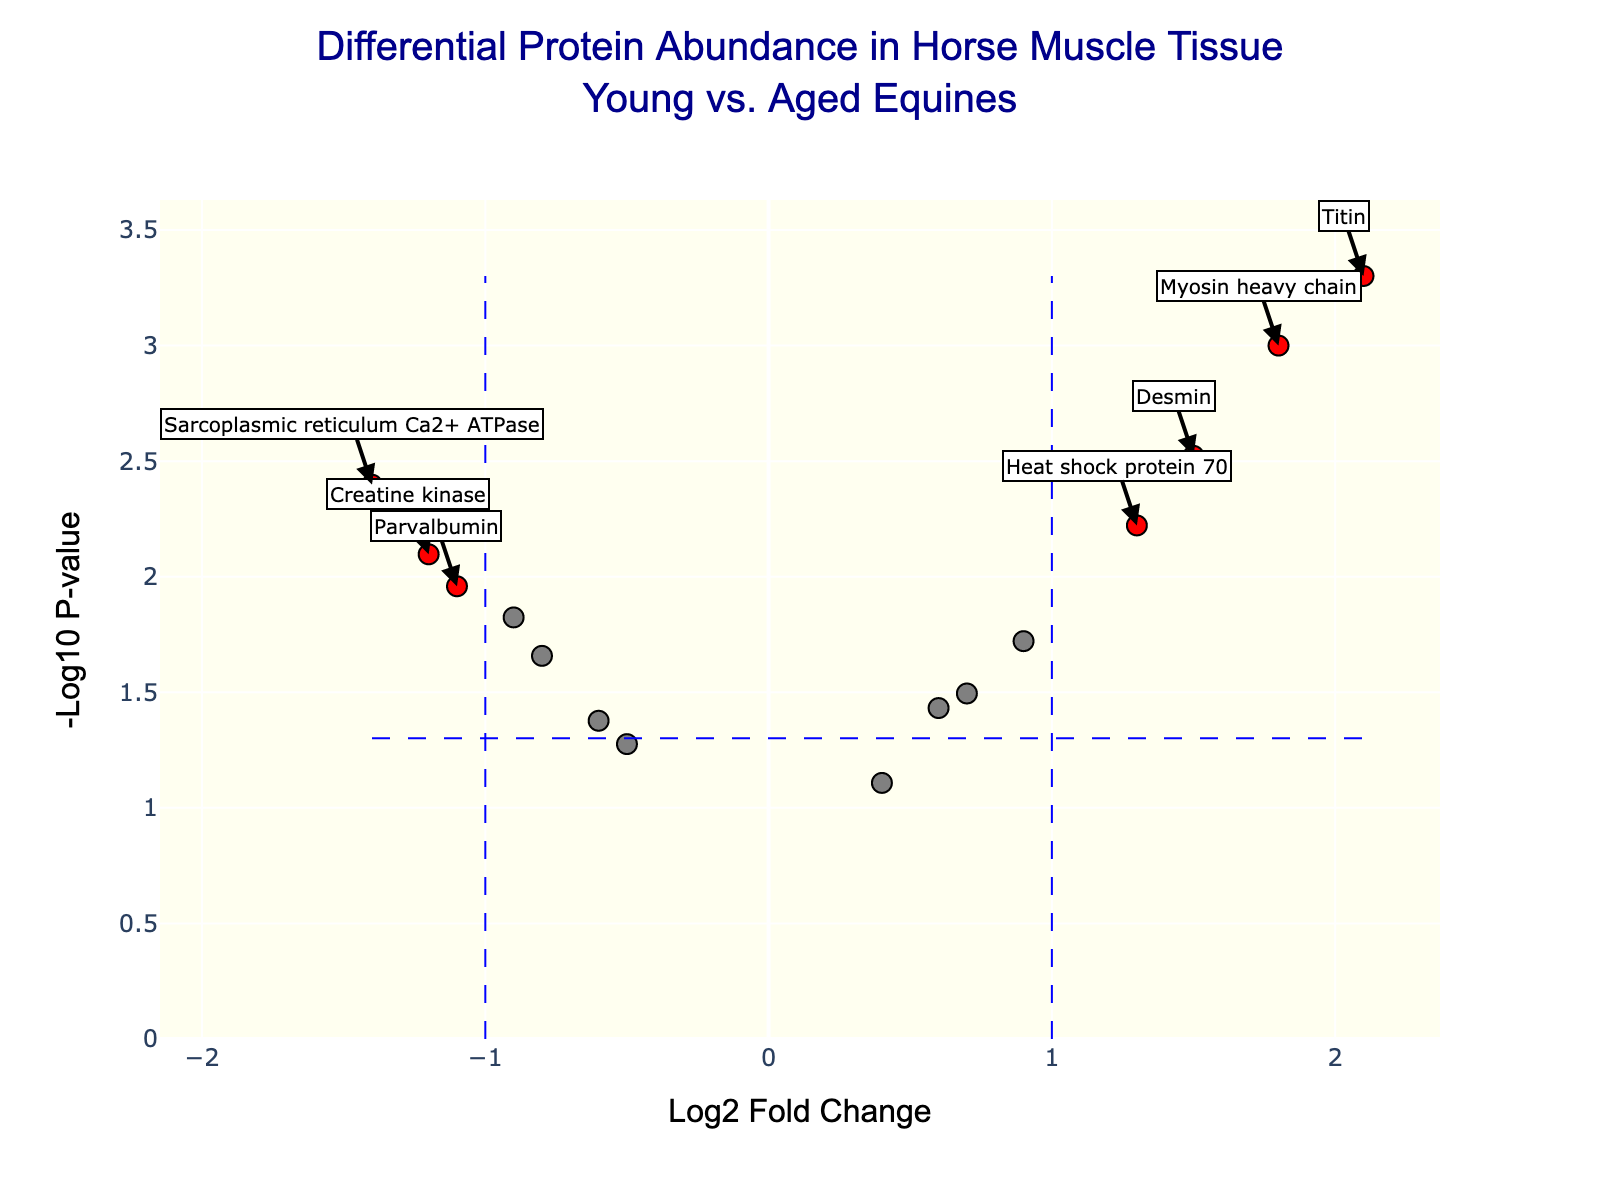How many proteins show significant changes in abundance? To determine the number of proteins with significant changes, we need to look for red dots in the plot because they indicate significance. There are dots with Log2FC magnitude > 1 and -log10(P-value) above a certain threshold. Count these red dots.
Answer: 9 Which protein shows the highest increase in abundance? Check the plot for the protein with the highest positive Log2FC value colored red (indicating significance). Titin on the far right has the highest Log2FC.
Answer: Titin What does the x-axis represent? The x-axis on the plot shows the Log2 Fold Change (Log2FC), indicating how much the abundance of each protein changes between young and aged equines.
Answer: Log2 Fold Change Which protein, among those significantly decreased, has the lowest p-value? Focus on the significant proteins that have a negative Log2FC (left side, colored red). The one with the highest -log10(P-value) (highest point vertically) among these is the answer. Sarcoplasmic reticulum Ca2+ ATPase is the highest among the decreasing proteins.
Answer: Sarcoplasmic reticulum Ca2+ ATPase How does the plot visually distinguish significant proteins from non-significant ones? Significant proteins are colored red, while non-significant proteins are colored gray. Additionally, significant proteins appear to cross the threshold lines, which help in visual distinction.
Answer: By color: red for significant, gray for non-significant Which protein is indicated at approximately Log2FC = 1.8 and -log10(P-value) = 3? Locate the dot around Log2FC = 1.8 and -log10(P-value) = 3 in the plot. The hover text or annotation shows it as Myosin heavy chain.
Answer: Myosin heavy chain How many proteins have a p-value less than 0.01? Proteins with a -log10(P-value) greater than 2 have p-values less than 0.01. Counting these dots on the plot shows which ones meet this criterion. We count Troponin T, Myosin heavy chain, Creatine kinase, Desmin, Titin, Heat shock protein 70, and Sarcoplasmic reticulum Ca2+ ATPase.
Answer: 7 Which protein shows the greatest decrease in abundance? Among the proteins with a negative Log2FC (left side), find the one with the most negative value, identified by the Log2FC position, which is the Sarcoplasmic reticulum Ca2+ ATPase with -1.4.
Answer: Sarcoplasmic reticulum Ca2+ ATPase Of the significant proteins, how many have an absolute Log2FC value greater than 1? Filter out significant proteins (red) and count how many have Log2FC values greater than 1 or less than -1 using vertical reference lines.
Answer: 7 